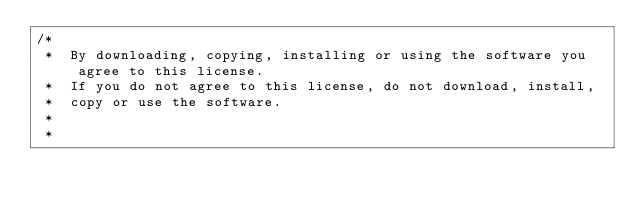Convert code to text. <code><loc_0><loc_0><loc_500><loc_500><_C++_>/*
 *  By downloading, copying, installing or using the software you agree to this license.
 *  If you do not agree to this license, do not download, install,
 *  copy or use the software.
 *
 *</code> 